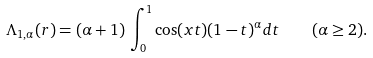<formula> <loc_0><loc_0><loc_500><loc_500>\Lambda _ { 1 , \alpha } ( r ) = ( \alpha + 1 ) \, \int _ { 0 } ^ { 1 } \cos ( x t ) ( 1 - t ) ^ { \alpha } d t \quad ( \alpha \geq 2 ) .</formula> 